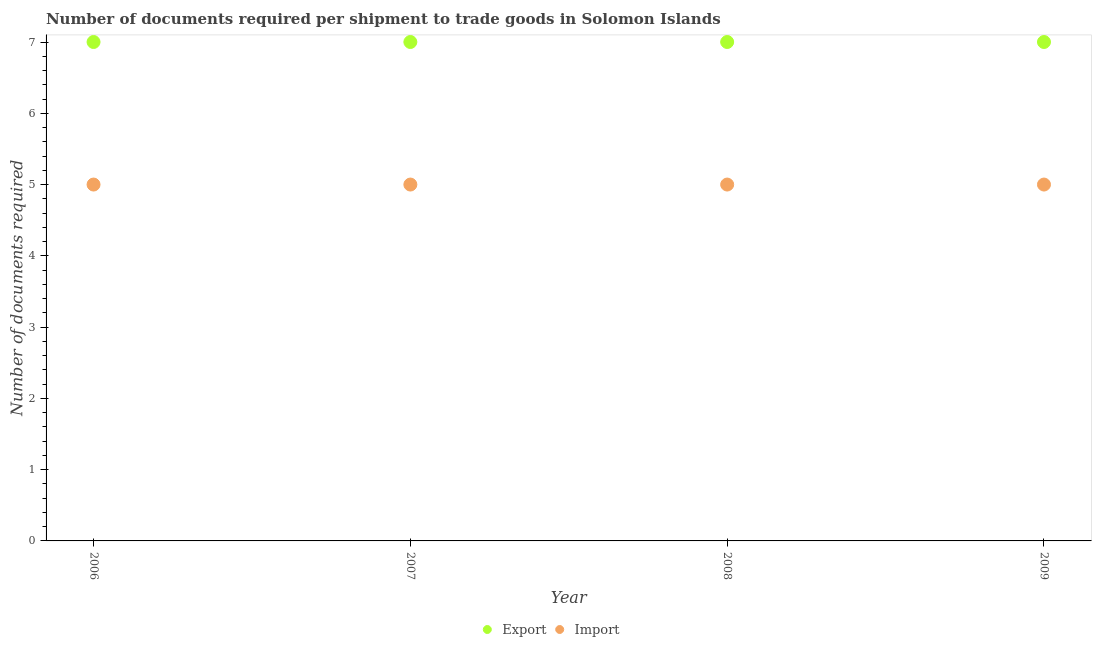Is the number of dotlines equal to the number of legend labels?
Keep it short and to the point. Yes. What is the number of documents required to export goods in 2008?
Offer a terse response. 7. Across all years, what is the maximum number of documents required to import goods?
Provide a succinct answer. 5. Across all years, what is the minimum number of documents required to export goods?
Your answer should be very brief. 7. In which year was the number of documents required to export goods maximum?
Keep it short and to the point. 2006. What is the total number of documents required to import goods in the graph?
Keep it short and to the point. 20. What is the difference between the number of documents required to export goods in 2007 and the number of documents required to import goods in 2009?
Provide a short and direct response. 2. What is the average number of documents required to export goods per year?
Provide a succinct answer. 7. In the year 2008, what is the difference between the number of documents required to import goods and number of documents required to export goods?
Provide a succinct answer. -2. Is the number of documents required to export goods in 2006 less than that in 2007?
Provide a short and direct response. No. Is the difference between the number of documents required to export goods in 2006 and 2007 greater than the difference between the number of documents required to import goods in 2006 and 2007?
Offer a terse response. No. What is the difference between the highest and the lowest number of documents required to import goods?
Give a very brief answer. 0. Is the sum of the number of documents required to export goods in 2006 and 2008 greater than the maximum number of documents required to import goods across all years?
Your answer should be compact. Yes. Does the number of documents required to export goods monotonically increase over the years?
Offer a terse response. No. How many years are there in the graph?
Your answer should be very brief. 4. Does the graph contain any zero values?
Keep it short and to the point. No. Does the graph contain grids?
Ensure brevity in your answer.  No. Where does the legend appear in the graph?
Your answer should be compact. Bottom center. What is the title of the graph?
Offer a terse response. Number of documents required per shipment to trade goods in Solomon Islands. What is the label or title of the Y-axis?
Provide a short and direct response. Number of documents required. What is the Number of documents required of Export in 2006?
Offer a terse response. 7. What is the Number of documents required in Import in 2006?
Offer a terse response. 5. What is the Number of documents required in Import in 2007?
Your answer should be compact. 5. What is the Number of documents required of Export in 2008?
Your answer should be very brief. 7. What is the Number of documents required of Import in 2009?
Ensure brevity in your answer.  5. Across all years, what is the maximum Number of documents required of Export?
Your answer should be compact. 7. Across all years, what is the minimum Number of documents required of Import?
Offer a terse response. 5. What is the total Number of documents required in Export in the graph?
Provide a short and direct response. 28. What is the total Number of documents required of Import in the graph?
Your answer should be compact. 20. What is the difference between the Number of documents required of Export in 2006 and that in 2007?
Offer a terse response. 0. What is the difference between the Number of documents required of Import in 2006 and that in 2007?
Make the answer very short. 0. What is the difference between the Number of documents required in Import in 2006 and that in 2008?
Offer a terse response. 0. What is the difference between the Number of documents required of Export in 2007 and that in 2008?
Provide a succinct answer. 0. What is the difference between the Number of documents required of Import in 2007 and that in 2008?
Offer a very short reply. 0. What is the difference between the Number of documents required in Export in 2006 and the Number of documents required in Import in 2007?
Your response must be concise. 2. What is the difference between the Number of documents required of Export in 2006 and the Number of documents required of Import in 2009?
Ensure brevity in your answer.  2. What is the difference between the Number of documents required of Export in 2007 and the Number of documents required of Import in 2008?
Your response must be concise. 2. In the year 2006, what is the difference between the Number of documents required in Export and Number of documents required in Import?
Your answer should be very brief. 2. What is the ratio of the Number of documents required in Export in 2006 to that in 2008?
Ensure brevity in your answer.  1. What is the ratio of the Number of documents required in Export in 2006 to that in 2009?
Your answer should be compact. 1. What is the ratio of the Number of documents required of Import in 2006 to that in 2009?
Provide a succinct answer. 1. What is the ratio of the Number of documents required in Export in 2008 to that in 2009?
Give a very brief answer. 1. What is the difference between the highest and the second highest Number of documents required of Import?
Offer a very short reply. 0. What is the difference between the highest and the lowest Number of documents required of Export?
Your answer should be compact. 0. 